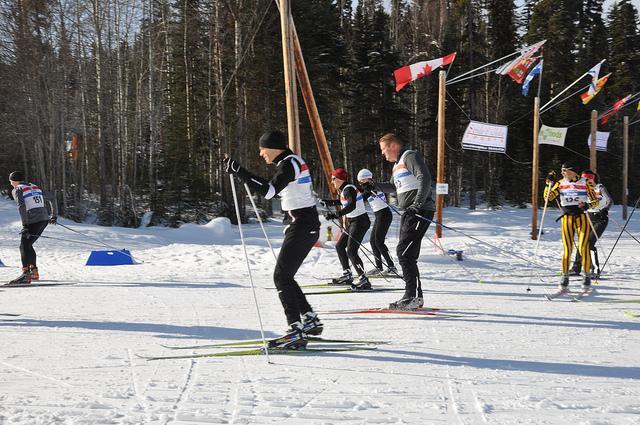How many skiers are there?
Give a very brief answer. 7. How many people are there?
Give a very brief answer. 5. How many kids are holding a laptop on their lap ?
Give a very brief answer. 0. 